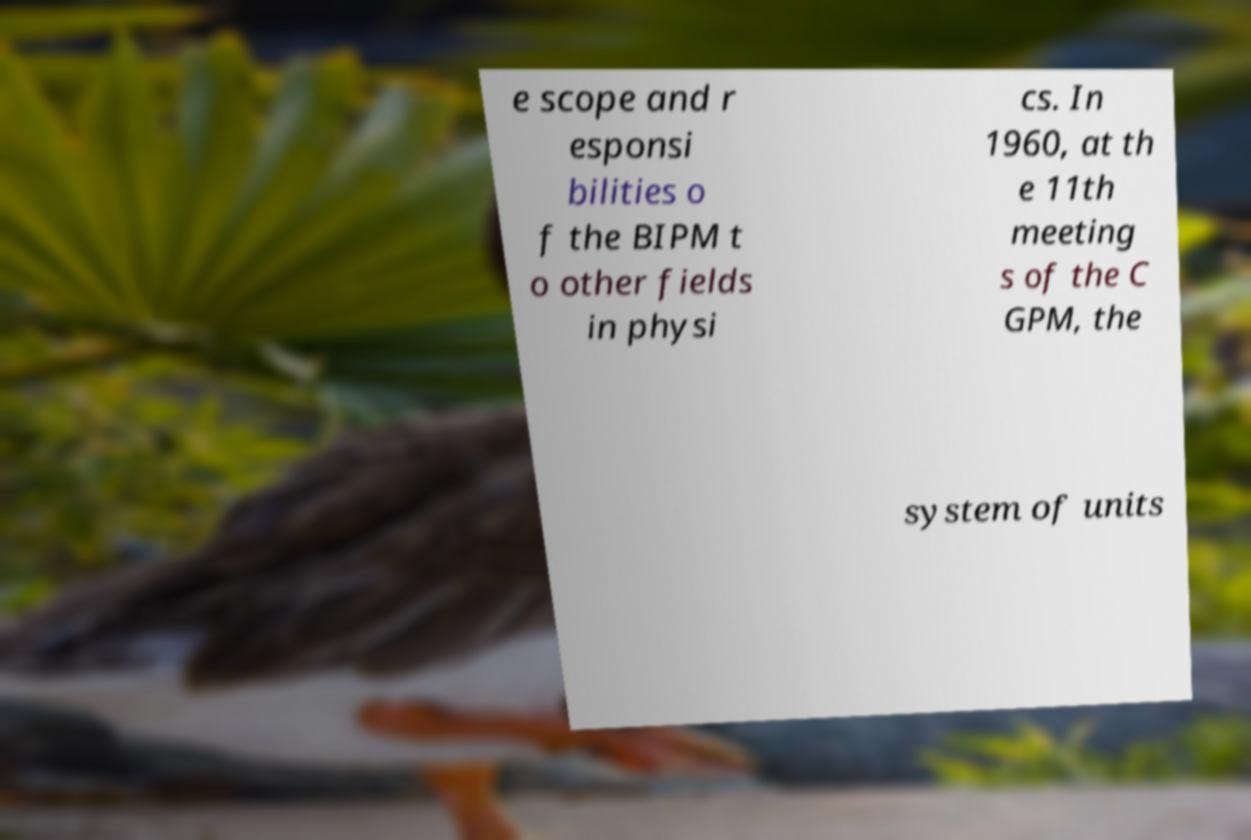Could you extract and type out the text from this image? e scope and r esponsi bilities o f the BIPM t o other fields in physi cs. In 1960, at th e 11th meeting s of the C GPM, the system of units 